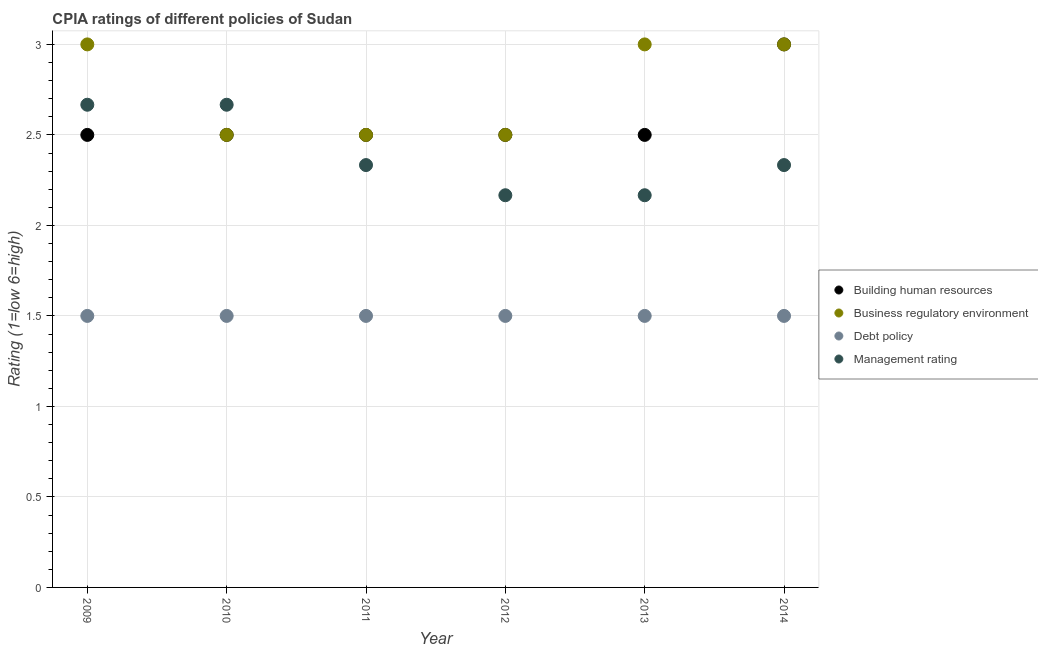Is the number of dotlines equal to the number of legend labels?
Keep it short and to the point. Yes. What is the cpia rating of business regulatory environment in 2013?
Offer a very short reply. 3. Across all years, what is the maximum cpia rating of business regulatory environment?
Provide a short and direct response. 3. Across all years, what is the minimum cpia rating of management?
Offer a very short reply. 2.17. In which year was the cpia rating of business regulatory environment minimum?
Give a very brief answer. 2010. What is the total cpia rating of building human resources in the graph?
Your answer should be very brief. 15.5. What is the difference between the cpia rating of management in 2011 and that in 2012?
Your answer should be very brief. 0.17. What is the average cpia rating of building human resources per year?
Keep it short and to the point. 2.58. In the year 2012, what is the difference between the cpia rating of debt policy and cpia rating of business regulatory environment?
Offer a terse response. -1. In how many years, is the cpia rating of debt policy greater than 0.7?
Make the answer very short. 6. What is the ratio of the cpia rating of business regulatory environment in 2012 to that in 2014?
Provide a short and direct response. 0.83. What is the difference between the highest and the second highest cpia rating of building human resources?
Offer a terse response. 0.5. Is the sum of the cpia rating of business regulatory environment in 2009 and 2014 greater than the maximum cpia rating of management across all years?
Offer a terse response. Yes. Is it the case that in every year, the sum of the cpia rating of business regulatory environment and cpia rating of debt policy is greater than the sum of cpia rating of building human resources and cpia rating of management?
Provide a succinct answer. No. Is the cpia rating of building human resources strictly greater than the cpia rating of management over the years?
Offer a very short reply. No. Is the cpia rating of business regulatory environment strictly less than the cpia rating of building human resources over the years?
Provide a short and direct response. No. How many years are there in the graph?
Your answer should be very brief. 6. Does the graph contain any zero values?
Your answer should be very brief. No. How many legend labels are there?
Offer a very short reply. 4. What is the title of the graph?
Offer a terse response. CPIA ratings of different policies of Sudan. Does "Norway" appear as one of the legend labels in the graph?
Make the answer very short. No. What is the Rating (1=low 6=high) in Building human resources in 2009?
Keep it short and to the point. 2.5. What is the Rating (1=low 6=high) in Management rating in 2009?
Provide a succinct answer. 2.67. What is the Rating (1=low 6=high) of Building human resources in 2010?
Keep it short and to the point. 2.5. What is the Rating (1=low 6=high) of Debt policy in 2010?
Offer a very short reply. 1.5. What is the Rating (1=low 6=high) of Management rating in 2010?
Offer a very short reply. 2.67. What is the Rating (1=low 6=high) in Debt policy in 2011?
Make the answer very short. 1.5. What is the Rating (1=low 6=high) of Management rating in 2011?
Your answer should be very brief. 2.33. What is the Rating (1=low 6=high) in Management rating in 2012?
Offer a terse response. 2.17. What is the Rating (1=low 6=high) in Building human resources in 2013?
Keep it short and to the point. 2.5. What is the Rating (1=low 6=high) of Management rating in 2013?
Offer a terse response. 2.17. What is the Rating (1=low 6=high) in Business regulatory environment in 2014?
Your answer should be very brief. 3. What is the Rating (1=low 6=high) in Debt policy in 2014?
Give a very brief answer. 1.5. What is the Rating (1=low 6=high) in Management rating in 2014?
Your answer should be very brief. 2.33. Across all years, what is the maximum Rating (1=low 6=high) in Building human resources?
Offer a terse response. 3. Across all years, what is the maximum Rating (1=low 6=high) of Business regulatory environment?
Offer a terse response. 3. Across all years, what is the maximum Rating (1=low 6=high) of Management rating?
Keep it short and to the point. 2.67. Across all years, what is the minimum Rating (1=low 6=high) in Building human resources?
Offer a terse response. 2.5. Across all years, what is the minimum Rating (1=low 6=high) in Business regulatory environment?
Your response must be concise. 2.5. Across all years, what is the minimum Rating (1=low 6=high) in Management rating?
Offer a very short reply. 2.17. What is the total Rating (1=low 6=high) of Building human resources in the graph?
Offer a terse response. 15.5. What is the total Rating (1=low 6=high) in Business regulatory environment in the graph?
Your response must be concise. 16.5. What is the total Rating (1=low 6=high) of Debt policy in the graph?
Your answer should be compact. 9. What is the total Rating (1=low 6=high) in Management rating in the graph?
Make the answer very short. 14.33. What is the difference between the Rating (1=low 6=high) of Business regulatory environment in 2009 and that in 2010?
Your answer should be compact. 0.5. What is the difference between the Rating (1=low 6=high) in Building human resources in 2009 and that in 2011?
Your response must be concise. 0. What is the difference between the Rating (1=low 6=high) of Management rating in 2009 and that in 2011?
Your response must be concise. 0.33. What is the difference between the Rating (1=low 6=high) of Building human resources in 2009 and that in 2012?
Provide a short and direct response. 0. What is the difference between the Rating (1=low 6=high) of Business regulatory environment in 2009 and that in 2012?
Offer a very short reply. 0.5. What is the difference between the Rating (1=low 6=high) in Debt policy in 2009 and that in 2012?
Provide a succinct answer. 0. What is the difference between the Rating (1=low 6=high) in Management rating in 2009 and that in 2012?
Ensure brevity in your answer.  0.5. What is the difference between the Rating (1=low 6=high) in Building human resources in 2009 and that in 2013?
Your answer should be compact. 0. What is the difference between the Rating (1=low 6=high) of Debt policy in 2009 and that in 2013?
Your answer should be very brief. 0. What is the difference between the Rating (1=low 6=high) in Building human resources in 2009 and that in 2014?
Give a very brief answer. -0.5. What is the difference between the Rating (1=low 6=high) of Business regulatory environment in 2010 and that in 2011?
Offer a terse response. 0. What is the difference between the Rating (1=low 6=high) of Debt policy in 2010 and that in 2011?
Give a very brief answer. 0. What is the difference between the Rating (1=low 6=high) in Management rating in 2010 and that in 2011?
Provide a succinct answer. 0.33. What is the difference between the Rating (1=low 6=high) in Building human resources in 2010 and that in 2012?
Provide a succinct answer. 0. What is the difference between the Rating (1=low 6=high) in Debt policy in 2010 and that in 2012?
Provide a succinct answer. 0. What is the difference between the Rating (1=low 6=high) in Management rating in 2010 and that in 2012?
Offer a very short reply. 0.5. What is the difference between the Rating (1=low 6=high) of Building human resources in 2010 and that in 2013?
Offer a very short reply. 0. What is the difference between the Rating (1=low 6=high) of Business regulatory environment in 2010 and that in 2013?
Your answer should be very brief. -0.5. What is the difference between the Rating (1=low 6=high) of Management rating in 2010 and that in 2013?
Offer a terse response. 0.5. What is the difference between the Rating (1=low 6=high) of Debt policy in 2010 and that in 2014?
Offer a terse response. 0. What is the difference between the Rating (1=low 6=high) of Building human resources in 2011 and that in 2012?
Your response must be concise. 0. What is the difference between the Rating (1=low 6=high) of Business regulatory environment in 2011 and that in 2012?
Your answer should be compact. 0. What is the difference between the Rating (1=low 6=high) of Management rating in 2011 and that in 2013?
Make the answer very short. 0.17. What is the difference between the Rating (1=low 6=high) of Building human resources in 2011 and that in 2014?
Ensure brevity in your answer.  -0.5. What is the difference between the Rating (1=low 6=high) of Business regulatory environment in 2011 and that in 2014?
Provide a short and direct response. -0.5. What is the difference between the Rating (1=low 6=high) in Debt policy in 2011 and that in 2014?
Make the answer very short. 0. What is the difference between the Rating (1=low 6=high) in Building human resources in 2012 and that in 2013?
Give a very brief answer. 0. What is the difference between the Rating (1=low 6=high) of Debt policy in 2012 and that in 2013?
Your answer should be very brief. 0. What is the difference between the Rating (1=low 6=high) in Management rating in 2012 and that in 2013?
Your answer should be very brief. 0. What is the difference between the Rating (1=low 6=high) in Building human resources in 2012 and that in 2014?
Ensure brevity in your answer.  -0.5. What is the difference between the Rating (1=low 6=high) of Debt policy in 2012 and that in 2014?
Your answer should be very brief. 0. What is the difference between the Rating (1=low 6=high) of Building human resources in 2013 and that in 2014?
Keep it short and to the point. -0.5. What is the difference between the Rating (1=low 6=high) of Business regulatory environment in 2009 and the Rating (1=low 6=high) of Debt policy in 2010?
Offer a terse response. 1.5. What is the difference between the Rating (1=low 6=high) of Business regulatory environment in 2009 and the Rating (1=low 6=high) of Management rating in 2010?
Provide a short and direct response. 0.33. What is the difference between the Rating (1=low 6=high) in Debt policy in 2009 and the Rating (1=low 6=high) in Management rating in 2010?
Provide a succinct answer. -1.17. What is the difference between the Rating (1=low 6=high) in Debt policy in 2009 and the Rating (1=low 6=high) in Management rating in 2011?
Your answer should be compact. -0.83. What is the difference between the Rating (1=low 6=high) of Building human resources in 2009 and the Rating (1=low 6=high) of Business regulatory environment in 2012?
Your answer should be compact. 0. What is the difference between the Rating (1=low 6=high) of Business regulatory environment in 2009 and the Rating (1=low 6=high) of Debt policy in 2012?
Provide a short and direct response. 1.5. What is the difference between the Rating (1=low 6=high) of Business regulatory environment in 2009 and the Rating (1=low 6=high) of Management rating in 2012?
Your answer should be very brief. 0.83. What is the difference between the Rating (1=low 6=high) of Debt policy in 2009 and the Rating (1=low 6=high) of Management rating in 2012?
Offer a very short reply. -0.67. What is the difference between the Rating (1=low 6=high) in Building human resources in 2009 and the Rating (1=low 6=high) in Debt policy in 2013?
Make the answer very short. 1. What is the difference between the Rating (1=low 6=high) in Business regulatory environment in 2009 and the Rating (1=low 6=high) in Debt policy in 2013?
Provide a succinct answer. 1.5. What is the difference between the Rating (1=low 6=high) in Building human resources in 2009 and the Rating (1=low 6=high) in Business regulatory environment in 2014?
Provide a succinct answer. -0.5. What is the difference between the Rating (1=low 6=high) of Building human resources in 2009 and the Rating (1=low 6=high) of Management rating in 2014?
Offer a very short reply. 0.17. What is the difference between the Rating (1=low 6=high) in Business regulatory environment in 2009 and the Rating (1=low 6=high) in Management rating in 2014?
Your response must be concise. 0.67. What is the difference between the Rating (1=low 6=high) of Building human resources in 2010 and the Rating (1=low 6=high) of Management rating in 2011?
Your response must be concise. 0.17. What is the difference between the Rating (1=low 6=high) of Building human resources in 2010 and the Rating (1=low 6=high) of Business regulatory environment in 2012?
Offer a very short reply. 0. What is the difference between the Rating (1=low 6=high) in Business regulatory environment in 2010 and the Rating (1=low 6=high) in Management rating in 2012?
Keep it short and to the point. 0.33. What is the difference between the Rating (1=low 6=high) in Building human resources in 2010 and the Rating (1=low 6=high) in Business regulatory environment in 2013?
Your response must be concise. -0.5. What is the difference between the Rating (1=low 6=high) in Building human resources in 2010 and the Rating (1=low 6=high) in Management rating in 2013?
Ensure brevity in your answer.  0.33. What is the difference between the Rating (1=low 6=high) in Business regulatory environment in 2010 and the Rating (1=low 6=high) in Management rating in 2013?
Make the answer very short. 0.33. What is the difference between the Rating (1=low 6=high) in Building human resources in 2010 and the Rating (1=low 6=high) in Management rating in 2014?
Keep it short and to the point. 0.17. What is the difference between the Rating (1=low 6=high) in Business regulatory environment in 2010 and the Rating (1=low 6=high) in Management rating in 2014?
Your response must be concise. 0.17. What is the difference between the Rating (1=low 6=high) of Debt policy in 2010 and the Rating (1=low 6=high) of Management rating in 2014?
Your response must be concise. -0.83. What is the difference between the Rating (1=low 6=high) of Building human resources in 2011 and the Rating (1=low 6=high) of Business regulatory environment in 2012?
Provide a short and direct response. 0. What is the difference between the Rating (1=low 6=high) of Building human resources in 2011 and the Rating (1=low 6=high) of Debt policy in 2012?
Offer a terse response. 1. What is the difference between the Rating (1=low 6=high) in Building human resources in 2011 and the Rating (1=low 6=high) in Management rating in 2012?
Offer a terse response. 0.33. What is the difference between the Rating (1=low 6=high) in Business regulatory environment in 2011 and the Rating (1=low 6=high) in Debt policy in 2012?
Provide a short and direct response. 1. What is the difference between the Rating (1=low 6=high) in Business regulatory environment in 2011 and the Rating (1=low 6=high) in Management rating in 2012?
Ensure brevity in your answer.  0.33. What is the difference between the Rating (1=low 6=high) of Building human resources in 2011 and the Rating (1=low 6=high) of Management rating in 2013?
Keep it short and to the point. 0.33. What is the difference between the Rating (1=low 6=high) in Business regulatory environment in 2011 and the Rating (1=low 6=high) in Debt policy in 2013?
Offer a very short reply. 1. What is the difference between the Rating (1=low 6=high) in Debt policy in 2011 and the Rating (1=low 6=high) in Management rating in 2013?
Provide a short and direct response. -0.67. What is the difference between the Rating (1=low 6=high) in Building human resources in 2011 and the Rating (1=low 6=high) in Business regulatory environment in 2014?
Offer a terse response. -0.5. What is the difference between the Rating (1=low 6=high) in Business regulatory environment in 2012 and the Rating (1=low 6=high) in Debt policy in 2013?
Your response must be concise. 1. What is the difference between the Rating (1=low 6=high) of Business regulatory environment in 2012 and the Rating (1=low 6=high) of Management rating in 2013?
Your answer should be compact. 0.33. What is the difference between the Rating (1=low 6=high) of Building human resources in 2012 and the Rating (1=low 6=high) of Debt policy in 2014?
Provide a short and direct response. 1. What is the difference between the Rating (1=low 6=high) in Building human resources in 2012 and the Rating (1=low 6=high) in Management rating in 2014?
Your answer should be compact. 0.17. What is the difference between the Rating (1=low 6=high) of Debt policy in 2012 and the Rating (1=low 6=high) of Management rating in 2014?
Your answer should be compact. -0.83. What is the difference between the Rating (1=low 6=high) in Business regulatory environment in 2013 and the Rating (1=low 6=high) in Management rating in 2014?
Provide a short and direct response. 0.67. What is the average Rating (1=low 6=high) in Building human resources per year?
Offer a terse response. 2.58. What is the average Rating (1=low 6=high) in Business regulatory environment per year?
Provide a succinct answer. 2.75. What is the average Rating (1=low 6=high) in Debt policy per year?
Your response must be concise. 1.5. What is the average Rating (1=low 6=high) of Management rating per year?
Give a very brief answer. 2.39. In the year 2009, what is the difference between the Rating (1=low 6=high) in Building human resources and Rating (1=low 6=high) in Business regulatory environment?
Ensure brevity in your answer.  -0.5. In the year 2009, what is the difference between the Rating (1=low 6=high) of Building human resources and Rating (1=low 6=high) of Management rating?
Your answer should be compact. -0.17. In the year 2009, what is the difference between the Rating (1=low 6=high) in Business regulatory environment and Rating (1=low 6=high) in Management rating?
Your response must be concise. 0.33. In the year 2009, what is the difference between the Rating (1=low 6=high) in Debt policy and Rating (1=low 6=high) in Management rating?
Give a very brief answer. -1.17. In the year 2010, what is the difference between the Rating (1=low 6=high) in Building human resources and Rating (1=low 6=high) in Business regulatory environment?
Ensure brevity in your answer.  0. In the year 2010, what is the difference between the Rating (1=low 6=high) of Building human resources and Rating (1=low 6=high) of Debt policy?
Your response must be concise. 1. In the year 2010, what is the difference between the Rating (1=low 6=high) in Building human resources and Rating (1=low 6=high) in Management rating?
Offer a very short reply. -0.17. In the year 2010, what is the difference between the Rating (1=low 6=high) in Business regulatory environment and Rating (1=low 6=high) in Debt policy?
Offer a very short reply. 1. In the year 2010, what is the difference between the Rating (1=low 6=high) in Business regulatory environment and Rating (1=low 6=high) in Management rating?
Provide a short and direct response. -0.17. In the year 2010, what is the difference between the Rating (1=low 6=high) of Debt policy and Rating (1=low 6=high) of Management rating?
Your answer should be compact. -1.17. In the year 2011, what is the difference between the Rating (1=low 6=high) of Building human resources and Rating (1=low 6=high) of Business regulatory environment?
Your response must be concise. 0. In the year 2011, what is the difference between the Rating (1=low 6=high) of Building human resources and Rating (1=low 6=high) of Debt policy?
Ensure brevity in your answer.  1. In the year 2011, what is the difference between the Rating (1=low 6=high) of Building human resources and Rating (1=low 6=high) of Management rating?
Your answer should be compact. 0.17. In the year 2011, what is the difference between the Rating (1=low 6=high) in Business regulatory environment and Rating (1=low 6=high) in Debt policy?
Keep it short and to the point. 1. In the year 2011, what is the difference between the Rating (1=low 6=high) in Business regulatory environment and Rating (1=low 6=high) in Management rating?
Offer a very short reply. 0.17. In the year 2011, what is the difference between the Rating (1=low 6=high) in Debt policy and Rating (1=low 6=high) in Management rating?
Keep it short and to the point. -0.83. In the year 2012, what is the difference between the Rating (1=low 6=high) of Building human resources and Rating (1=low 6=high) of Business regulatory environment?
Provide a short and direct response. 0. In the year 2012, what is the difference between the Rating (1=low 6=high) of Business regulatory environment and Rating (1=low 6=high) of Debt policy?
Give a very brief answer. 1. In the year 2013, what is the difference between the Rating (1=low 6=high) in Building human resources and Rating (1=low 6=high) in Debt policy?
Offer a terse response. 1. In the year 2013, what is the difference between the Rating (1=low 6=high) of Business regulatory environment and Rating (1=low 6=high) of Management rating?
Your answer should be compact. 0.83. In the year 2014, what is the difference between the Rating (1=low 6=high) of Building human resources and Rating (1=low 6=high) of Business regulatory environment?
Provide a succinct answer. 0. In the year 2014, what is the difference between the Rating (1=low 6=high) in Building human resources and Rating (1=low 6=high) in Debt policy?
Keep it short and to the point. 1.5. In the year 2014, what is the difference between the Rating (1=low 6=high) of Building human resources and Rating (1=low 6=high) of Management rating?
Make the answer very short. 0.67. In the year 2014, what is the difference between the Rating (1=low 6=high) in Business regulatory environment and Rating (1=low 6=high) in Debt policy?
Give a very brief answer. 1.5. In the year 2014, what is the difference between the Rating (1=low 6=high) of Debt policy and Rating (1=low 6=high) of Management rating?
Provide a short and direct response. -0.83. What is the ratio of the Rating (1=low 6=high) in Building human resources in 2009 to that in 2010?
Provide a succinct answer. 1. What is the ratio of the Rating (1=low 6=high) in Building human resources in 2009 to that in 2011?
Offer a very short reply. 1. What is the ratio of the Rating (1=low 6=high) in Management rating in 2009 to that in 2012?
Keep it short and to the point. 1.23. What is the ratio of the Rating (1=low 6=high) of Building human resources in 2009 to that in 2013?
Give a very brief answer. 1. What is the ratio of the Rating (1=low 6=high) of Business regulatory environment in 2009 to that in 2013?
Ensure brevity in your answer.  1. What is the ratio of the Rating (1=low 6=high) in Management rating in 2009 to that in 2013?
Provide a succinct answer. 1.23. What is the ratio of the Rating (1=low 6=high) of Building human resources in 2009 to that in 2014?
Your answer should be compact. 0.83. What is the ratio of the Rating (1=low 6=high) in Business regulatory environment in 2009 to that in 2014?
Keep it short and to the point. 1. What is the ratio of the Rating (1=low 6=high) in Business regulatory environment in 2010 to that in 2011?
Give a very brief answer. 1. What is the ratio of the Rating (1=low 6=high) of Debt policy in 2010 to that in 2011?
Offer a very short reply. 1. What is the ratio of the Rating (1=low 6=high) of Building human resources in 2010 to that in 2012?
Your answer should be very brief. 1. What is the ratio of the Rating (1=low 6=high) of Business regulatory environment in 2010 to that in 2012?
Your answer should be very brief. 1. What is the ratio of the Rating (1=low 6=high) of Management rating in 2010 to that in 2012?
Your answer should be compact. 1.23. What is the ratio of the Rating (1=low 6=high) of Debt policy in 2010 to that in 2013?
Your response must be concise. 1. What is the ratio of the Rating (1=low 6=high) in Management rating in 2010 to that in 2013?
Provide a short and direct response. 1.23. What is the ratio of the Rating (1=low 6=high) in Building human resources in 2011 to that in 2014?
Offer a terse response. 0.83. What is the ratio of the Rating (1=low 6=high) of Business regulatory environment in 2011 to that in 2014?
Make the answer very short. 0.83. What is the ratio of the Rating (1=low 6=high) in Building human resources in 2012 to that in 2013?
Ensure brevity in your answer.  1. What is the ratio of the Rating (1=low 6=high) in Debt policy in 2012 to that in 2013?
Your answer should be very brief. 1. What is the ratio of the Rating (1=low 6=high) of Business regulatory environment in 2012 to that in 2014?
Offer a very short reply. 0.83. What is the ratio of the Rating (1=low 6=high) in Debt policy in 2012 to that in 2014?
Offer a very short reply. 1. What is the ratio of the Rating (1=low 6=high) in Building human resources in 2013 to that in 2014?
Ensure brevity in your answer.  0.83. What is the ratio of the Rating (1=low 6=high) in Business regulatory environment in 2013 to that in 2014?
Offer a very short reply. 1. What is the ratio of the Rating (1=low 6=high) of Debt policy in 2013 to that in 2014?
Your answer should be very brief. 1. What is the ratio of the Rating (1=low 6=high) in Management rating in 2013 to that in 2014?
Offer a terse response. 0.93. What is the difference between the highest and the second highest Rating (1=low 6=high) of Building human resources?
Keep it short and to the point. 0.5. What is the difference between the highest and the second highest Rating (1=low 6=high) in Management rating?
Ensure brevity in your answer.  0. 